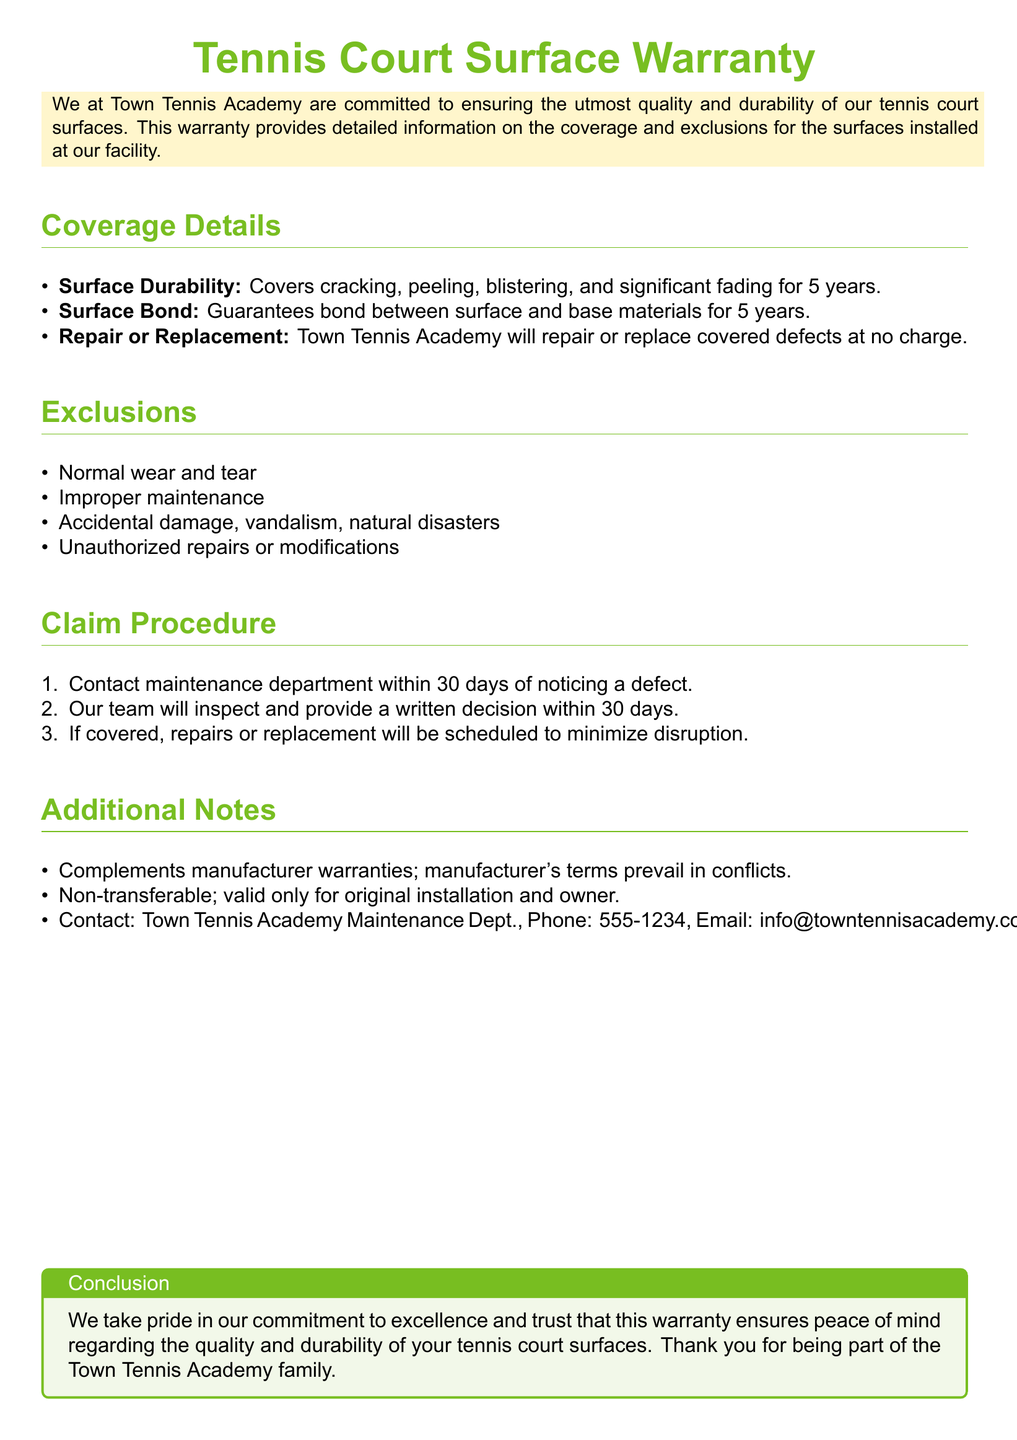What is the warranty period for surface durability? The warranty clearly states that it covers surface durability for 5 years.
Answer: 5 years What types of damage are covered under this warranty? The document specifies damage such as cracking, peeling, blistering, and significant fading as covered.
Answer: Cracking, peeling, blistering, significant fading What must you do within 30 days of noticing a defect? The document mentions that you must contact the maintenance department within 30 days.
Answer: Contact maintenance department What are the exclusions of the warranty? The warranty excludes normal wear and tear, improper maintenance, accidental damage, vandalism, and natural disasters.
Answer: Normal wear and tear, improper maintenance, accidental damage, vandalism, natural disasters Who should be contacted for warranty claims? The document provides contact information for the Town Tennis Academy Maintenance Department for warranty claims.
Answer: Town Tennis Academy Maintenance Dept What happens if there are unauthorized repairs? The warranty states that unauthorized repairs or modifications are excluded from coverage.
Answer: Excluded What is the timeframe for the written decision after reporting a defect? The document indicates that a written decision will be provided within 30 days of inspection.
Answer: 30 days Is the warranty transferable? The warranty specifies that it is non-transferable and valid only for the original installation and owner.
Answer: Non-transferable 